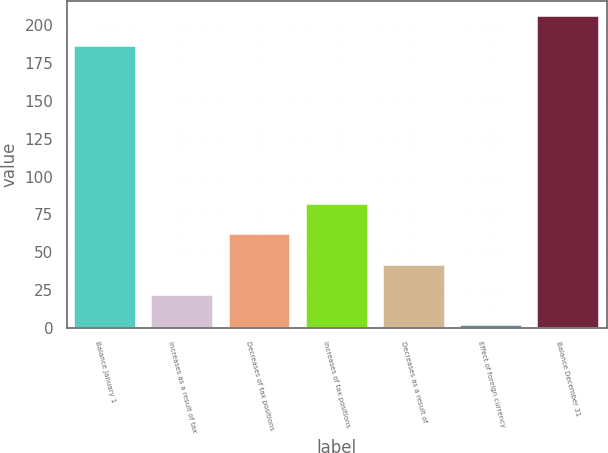<chart> <loc_0><loc_0><loc_500><loc_500><bar_chart><fcel>Balance January 1<fcel>Increases as a result of tax<fcel>Decreases of tax positions<fcel>Increases of tax positions<fcel>Decreases as a result of<fcel>Effect of foreign currency<fcel>Balance December 31<nl><fcel>186<fcel>21.9<fcel>61.7<fcel>81.6<fcel>41.8<fcel>2<fcel>205.9<nl></chart> 